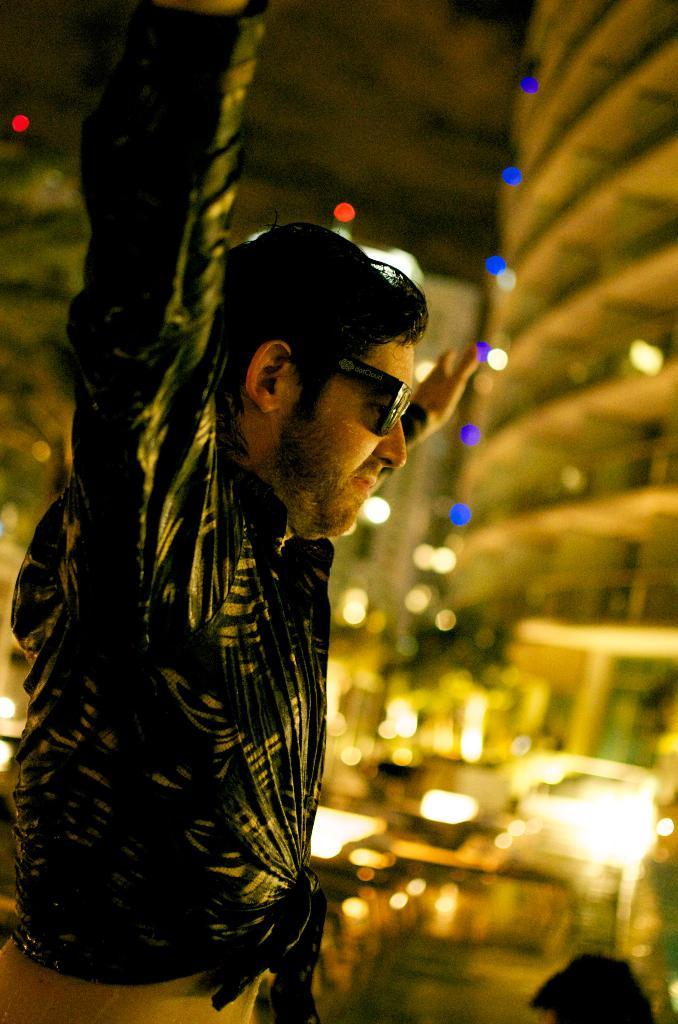What can be seen in the image? There is a person in the image. What is the person wearing on their face? The person is wearing black goggles. How would you describe the background of the image? The background of the image is blurred. What else can be seen in the background of the image? There are lights and buildings in the background of the image. What type of crown is the beast wearing in the image? There is no beast or crown present in the image. Is the library visible in the background of the image? There is no library visible in the image; only lights and buildings can be seen in the background. 